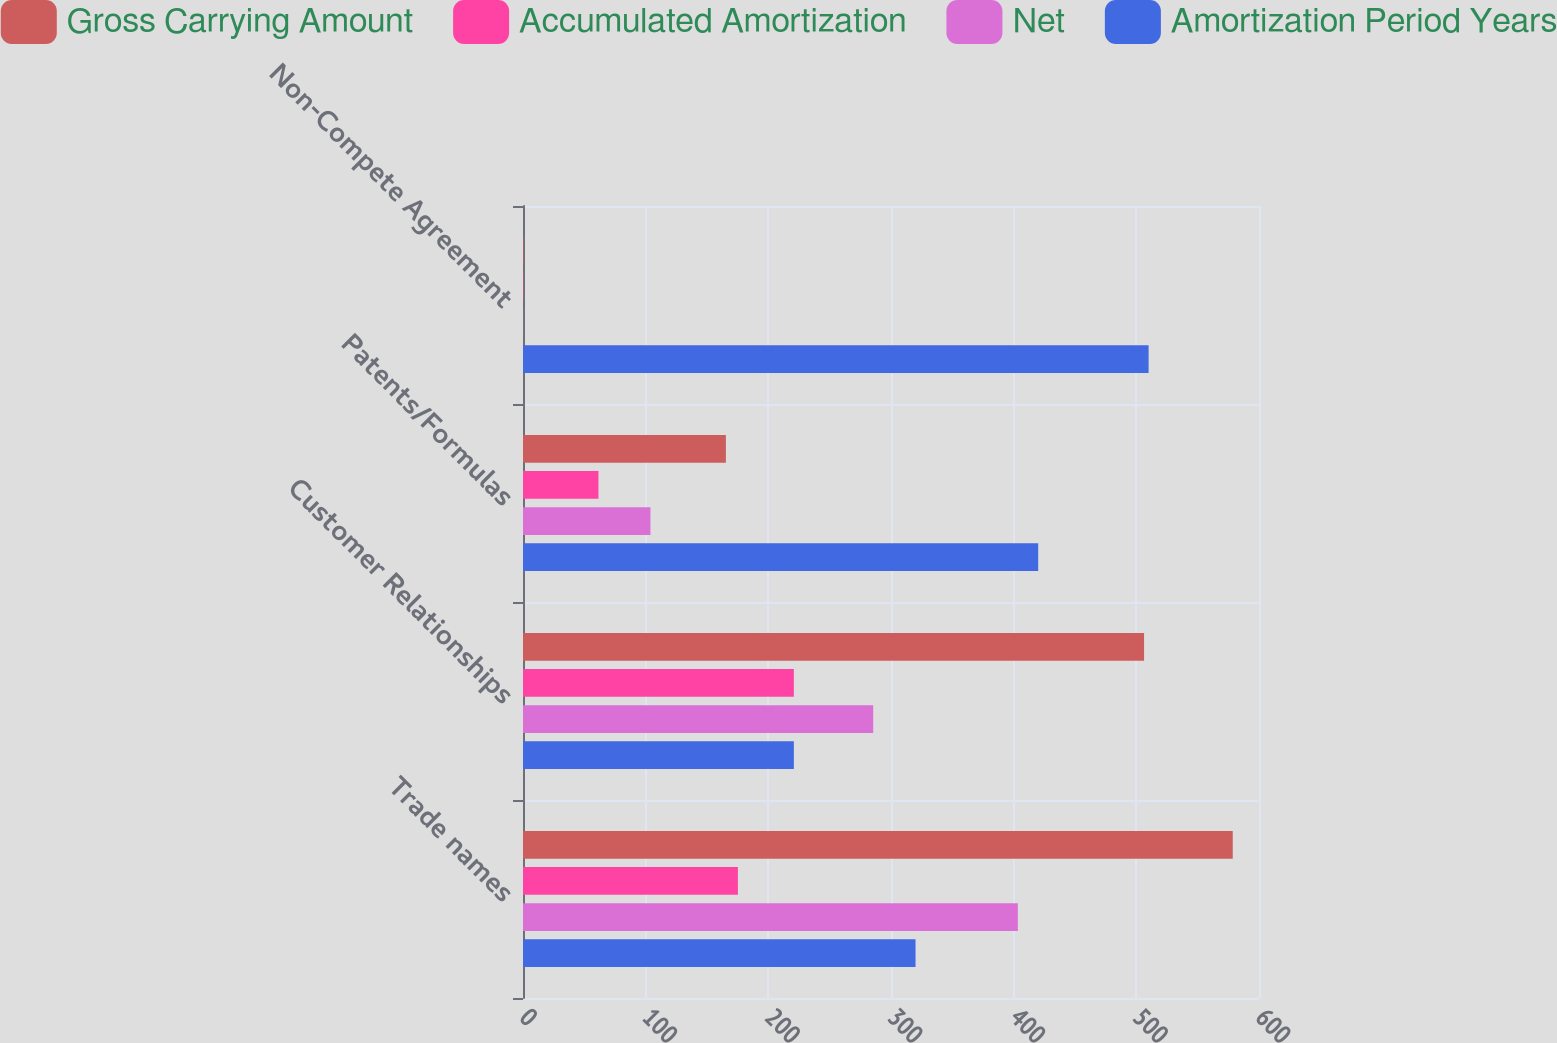<chart> <loc_0><loc_0><loc_500><loc_500><stacked_bar_chart><ecel><fcel>Trade names<fcel>Customer Relationships<fcel>Patents/Formulas<fcel>Non-Compete Agreement<nl><fcel>Gross Carrying Amount<fcel>578.6<fcel>506.3<fcel>165.4<fcel>0.4<nl><fcel>Accumulated Amortization<fcel>175.2<fcel>220.8<fcel>61.5<fcel>0.3<nl><fcel>Net<fcel>403.4<fcel>285.5<fcel>103.9<fcel>0.1<nl><fcel>Amortization Period Years<fcel>320<fcel>220.8<fcel>420<fcel>510<nl></chart> 